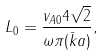<formula> <loc_0><loc_0><loc_500><loc_500>L _ { 0 } = \frac { v _ { A 0 } 4 \sqrt { 2 } } { \omega \pi ( \bar { k } a ) } ,</formula> 